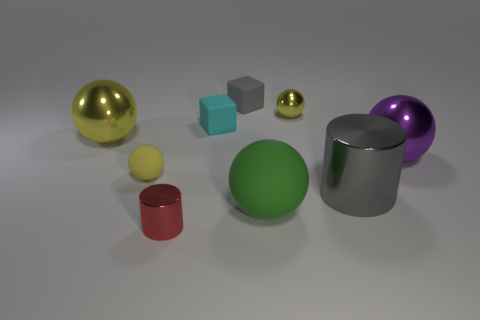How many yellow balls must be subtracted to get 2 yellow balls? 1 Subtract all spheres. How many objects are left? 4 Subtract 2 cylinders. How many cylinders are left? 0 Subtract all brown spheres. Subtract all cyan cylinders. How many spheres are left? 5 Subtract all gray spheres. How many green cylinders are left? 0 Subtract all small gray rubber blocks. Subtract all blocks. How many objects are left? 6 Add 3 cylinders. How many cylinders are left? 5 Add 1 large yellow things. How many large yellow things exist? 2 Subtract all green spheres. How many spheres are left? 4 Subtract all green spheres. How many spheres are left? 4 